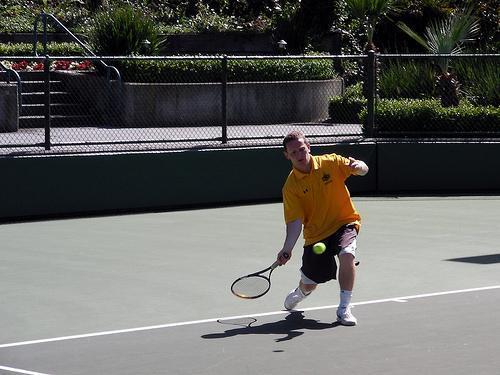How many steps are visible?
Give a very brief answer. 5. 